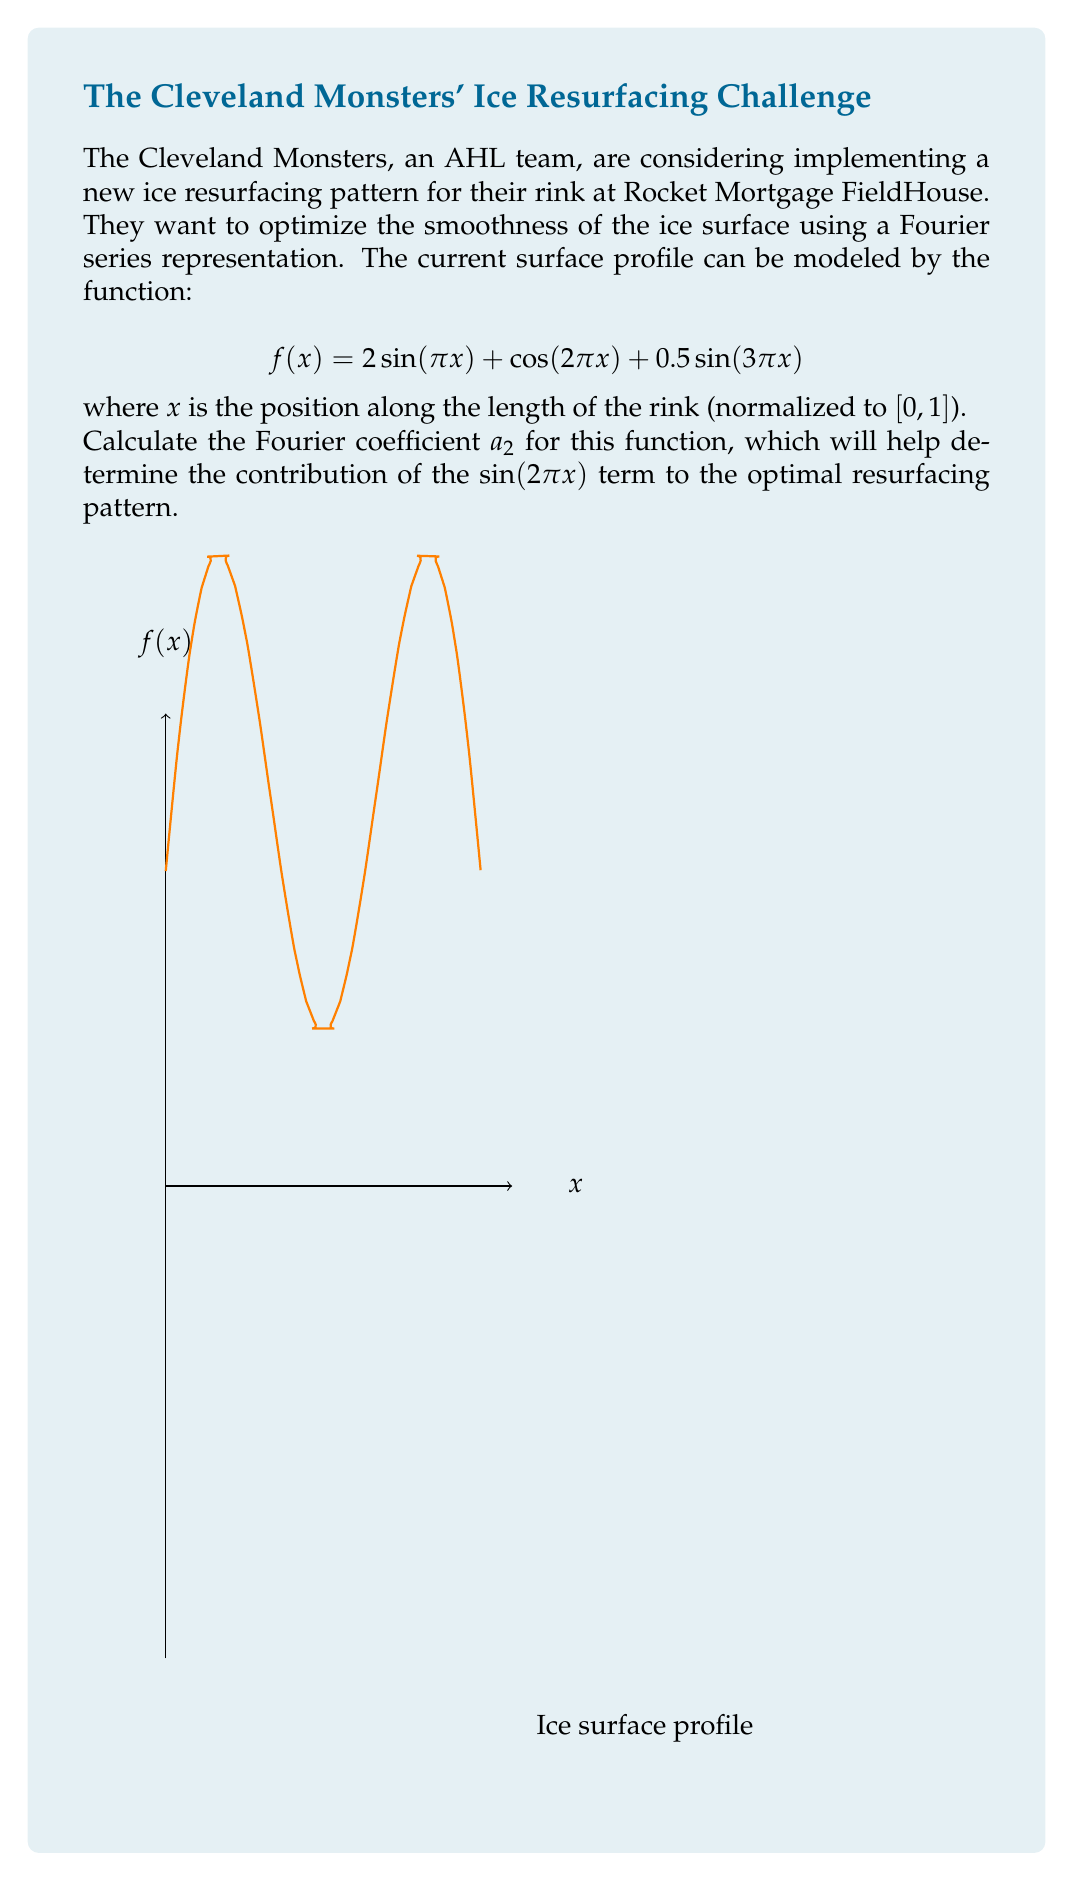Teach me how to tackle this problem. To find the Fourier coefficient $a_2$, we need to use the formula:

$$a_n = 2 \int_0^1 f(x) \sin(n\pi x) dx$$

For $a_2$, we have $n=2$. Let's substitute our function and integrate:

$$a_2 = 2 \int_0^1 (2 \sin(\pi x) + \cos(2\pi x) + 0.5 \sin(3\pi x)) \sin(2\pi x) dx$$

We can break this into three integrals:

1) $4 \int_0^1 \sin(\pi x) \sin(2\pi x) dx$
2) $2 \int_0^1 \cos(2\pi x) \sin(2\pi x) dx$
3) $\int_0^1 \sin(3\pi x) \sin(2\pi x) dx$

For the first integral, we can use the trigonometric identity:
$$\sin A \sin B = \frac{1}{2}[\cos(A-B) - \cos(A+B)]$$

$$4 \int_0^1 \sin(\pi x) \sin(2\pi x) dx = 2 \int_0^1 [\cos(\pi x) - \cos(3\pi x)] dx = 2 [\frac{\sin(\pi x)}{\pi} - \frac{\sin(3\pi x)}{3\pi}]_0^1 = 0$$

For the second integral:
$$2 \int_0^1 \cos(2\pi x) \sin(2\pi x) dx = \int_0^1 \sin(4\pi x) dx = -\frac{1}{4\pi}[\cos(4\pi x)]_0^1 = 0$$

For the third integral, using the same identity as before:
$$\int_0^1 \sin(3\pi x) \sin(2\pi x) dx = \frac{1}{2} \int_0^1 [\cos(\pi x) - \cos(5\pi x)] dx = \frac{1}{2} [\frac{\sin(\pi x)}{\pi} - \frac{\sin(5\pi x)}{5\pi}]_0^1 = 0$$

Adding all these results:

$$a_2 = 0 + 0 + 0 = 0$$
Answer: $a_2 = 0$ 